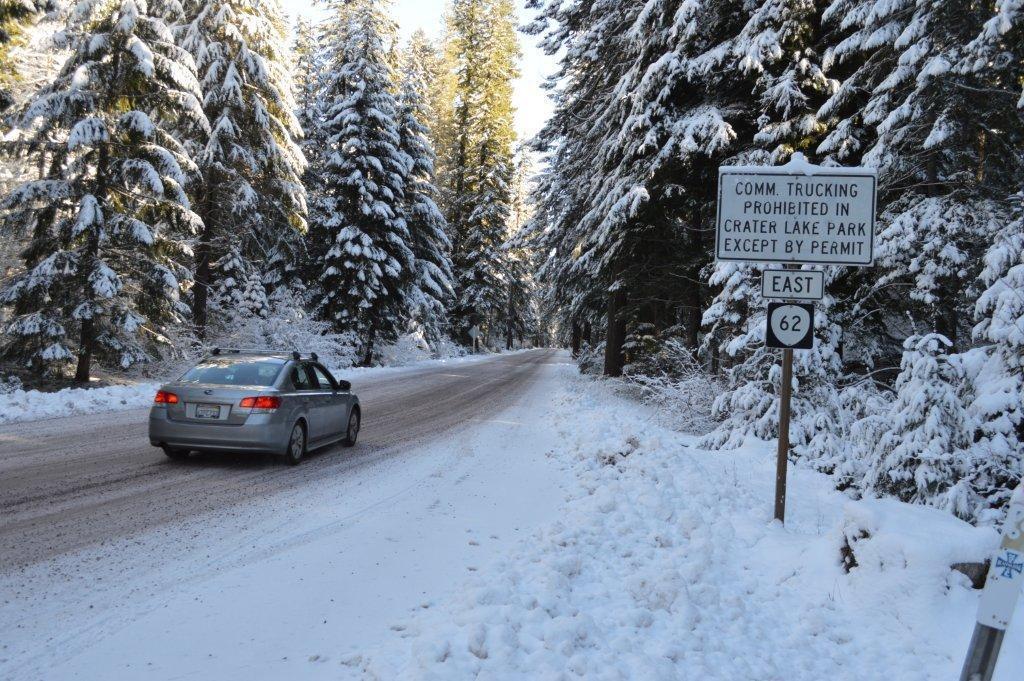In one or two sentences, can you explain what this image depicts? In this image I can see a car on the road, the car is in gray color. I can also see few trees covered with snow and a white color board attached to the pole. Background the sky is in white color. 